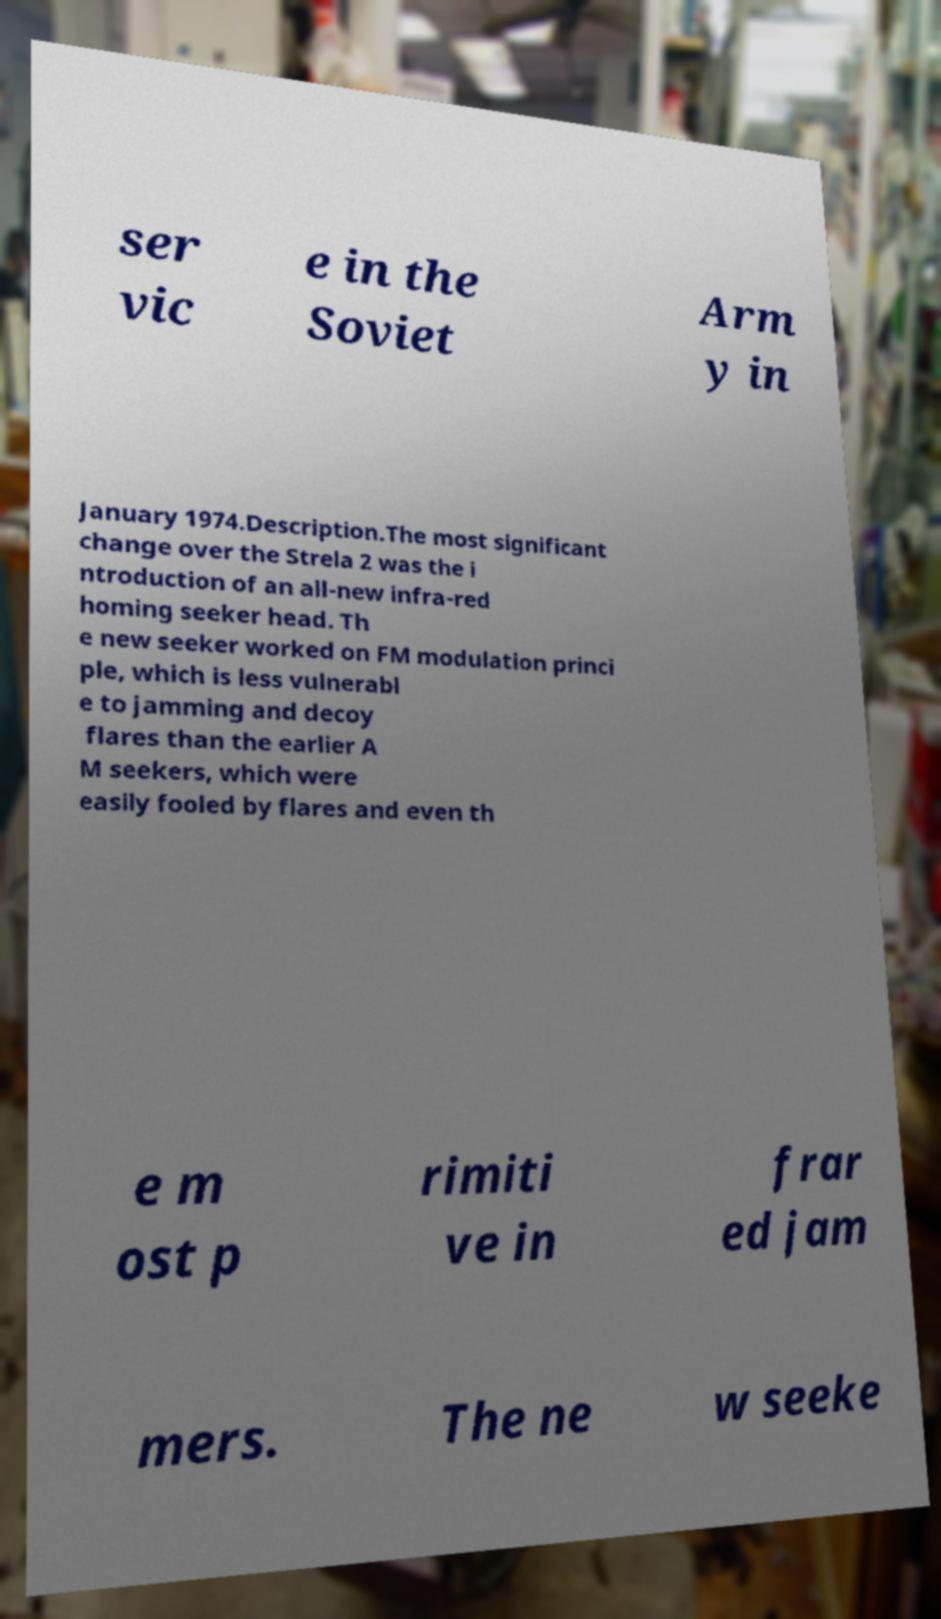What messages or text are displayed in this image? I need them in a readable, typed format. ser vic e in the Soviet Arm y in January 1974.Description.The most significant change over the Strela 2 was the i ntroduction of an all-new infra-red homing seeker head. Th e new seeker worked on FM modulation princi ple, which is less vulnerabl e to jamming and decoy flares than the earlier A M seekers, which were easily fooled by flares and even th e m ost p rimiti ve in frar ed jam mers. The ne w seeke 